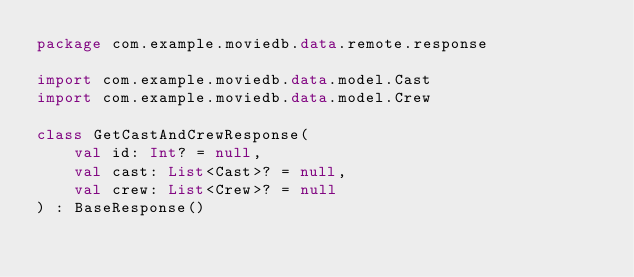<code> <loc_0><loc_0><loc_500><loc_500><_Kotlin_>package com.example.moviedb.data.remote.response

import com.example.moviedb.data.model.Cast
import com.example.moviedb.data.model.Crew

class GetCastAndCrewResponse(
    val id: Int? = null,
    val cast: List<Cast>? = null,
    val crew: List<Crew>? = null
) : BaseResponse()</code> 